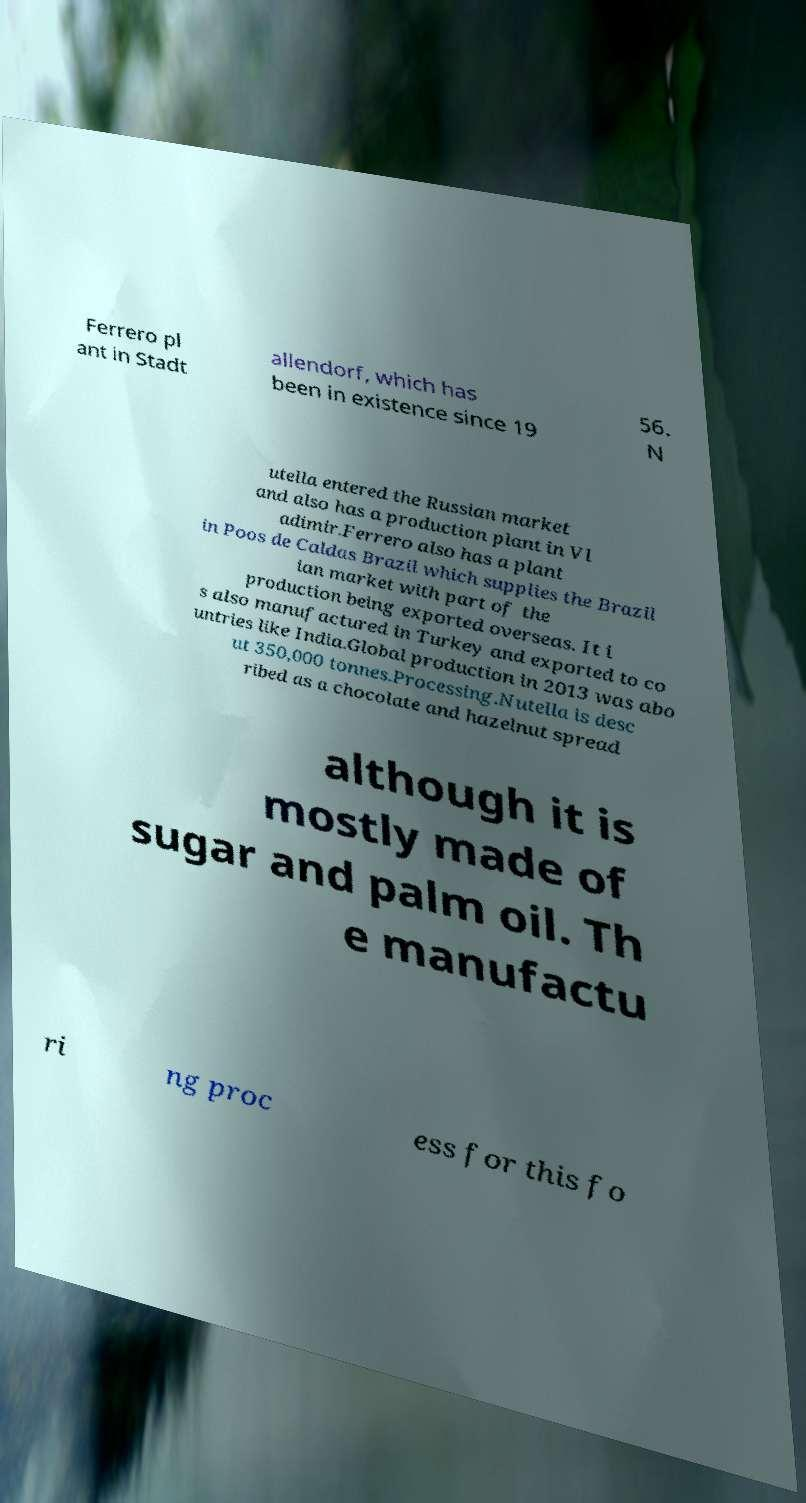Could you assist in decoding the text presented in this image and type it out clearly? Ferrero pl ant in Stadt allendorf, which has been in existence since 19 56. N utella entered the Russian market and also has a production plant in Vl adimir.Ferrero also has a plant in Poos de Caldas Brazil which supplies the Brazil ian market with part of the production being exported overseas. It i s also manufactured in Turkey and exported to co untries like India.Global production in 2013 was abo ut 350,000 tonnes.Processing.Nutella is desc ribed as a chocolate and hazelnut spread although it is mostly made of sugar and palm oil. Th e manufactu ri ng proc ess for this fo 